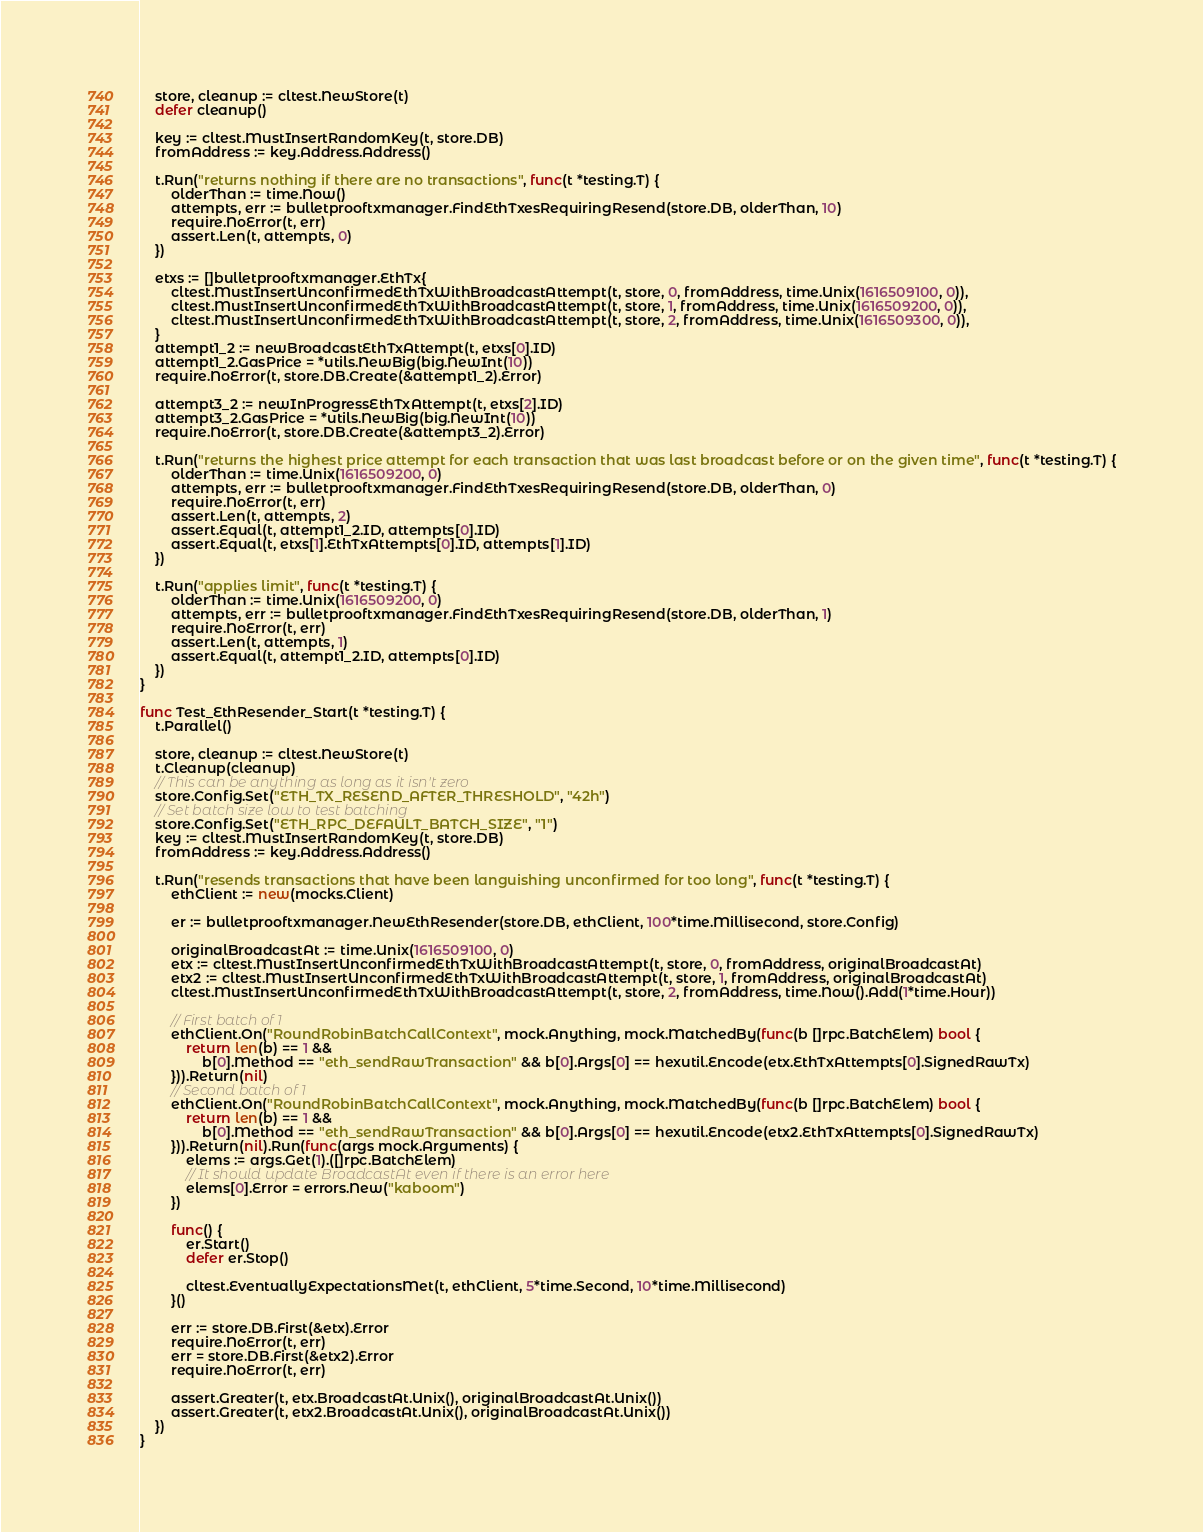<code> <loc_0><loc_0><loc_500><loc_500><_Go_>
	store, cleanup := cltest.NewStore(t)
	defer cleanup()

	key := cltest.MustInsertRandomKey(t, store.DB)
	fromAddress := key.Address.Address()

	t.Run("returns nothing if there are no transactions", func(t *testing.T) {
		olderThan := time.Now()
		attempts, err := bulletprooftxmanager.FindEthTxesRequiringResend(store.DB, olderThan, 10)
		require.NoError(t, err)
		assert.Len(t, attempts, 0)
	})

	etxs := []bulletprooftxmanager.EthTx{
		cltest.MustInsertUnconfirmedEthTxWithBroadcastAttempt(t, store, 0, fromAddress, time.Unix(1616509100, 0)),
		cltest.MustInsertUnconfirmedEthTxWithBroadcastAttempt(t, store, 1, fromAddress, time.Unix(1616509200, 0)),
		cltest.MustInsertUnconfirmedEthTxWithBroadcastAttempt(t, store, 2, fromAddress, time.Unix(1616509300, 0)),
	}
	attempt1_2 := newBroadcastEthTxAttempt(t, etxs[0].ID)
	attempt1_2.GasPrice = *utils.NewBig(big.NewInt(10))
	require.NoError(t, store.DB.Create(&attempt1_2).Error)

	attempt3_2 := newInProgressEthTxAttempt(t, etxs[2].ID)
	attempt3_2.GasPrice = *utils.NewBig(big.NewInt(10))
	require.NoError(t, store.DB.Create(&attempt3_2).Error)

	t.Run("returns the highest price attempt for each transaction that was last broadcast before or on the given time", func(t *testing.T) {
		olderThan := time.Unix(1616509200, 0)
		attempts, err := bulletprooftxmanager.FindEthTxesRequiringResend(store.DB, olderThan, 0)
		require.NoError(t, err)
		assert.Len(t, attempts, 2)
		assert.Equal(t, attempt1_2.ID, attempts[0].ID)
		assert.Equal(t, etxs[1].EthTxAttempts[0].ID, attempts[1].ID)
	})

	t.Run("applies limit", func(t *testing.T) {
		olderThan := time.Unix(1616509200, 0)
		attempts, err := bulletprooftxmanager.FindEthTxesRequiringResend(store.DB, olderThan, 1)
		require.NoError(t, err)
		assert.Len(t, attempts, 1)
		assert.Equal(t, attempt1_2.ID, attempts[0].ID)
	})
}

func Test_EthResender_Start(t *testing.T) {
	t.Parallel()

	store, cleanup := cltest.NewStore(t)
	t.Cleanup(cleanup)
	// This can be anything as long as it isn't zero
	store.Config.Set("ETH_TX_RESEND_AFTER_THRESHOLD", "42h")
	// Set batch size low to test batching
	store.Config.Set("ETH_RPC_DEFAULT_BATCH_SIZE", "1")
	key := cltest.MustInsertRandomKey(t, store.DB)
	fromAddress := key.Address.Address()

	t.Run("resends transactions that have been languishing unconfirmed for too long", func(t *testing.T) {
		ethClient := new(mocks.Client)

		er := bulletprooftxmanager.NewEthResender(store.DB, ethClient, 100*time.Millisecond, store.Config)

		originalBroadcastAt := time.Unix(1616509100, 0)
		etx := cltest.MustInsertUnconfirmedEthTxWithBroadcastAttempt(t, store, 0, fromAddress, originalBroadcastAt)
		etx2 := cltest.MustInsertUnconfirmedEthTxWithBroadcastAttempt(t, store, 1, fromAddress, originalBroadcastAt)
		cltest.MustInsertUnconfirmedEthTxWithBroadcastAttempt(t, store, 2, fromAddress, time.Now().Add(1*time.Hour))

		// First batch of 1
		ethClient.On("RoundRobinBatchCallContext", mock.Anything, mock.MatchedBy(func(b []rpc.BatchElem) bool {
			return len(b) == 1 &&
				b[0].Method == "eth_sendRawTransaction" && b[0].Args[0] == hexutil.Encode(etx.EthTxAttempts[0].SignedRawTx)
		})).Return(nil)
		// Second batch of 1
		ethClient.On("RoundRobinBatchCallContext", mock.Anything, mock.MatchedBy(func(b []rpc.BatchElem) bool {
			return len(b) == 1 &&
				b[0].Method == "eth_sendRawTransaction" && b[0].Args[0] == hexutil.Encode(etx2.EthTxAttempts[0].SignedRawTx)
		})).Return(nil).Run(func(args mock.Arguments) {
			elems := args.Get(1).([]rpc.BatchElem)
			// It should update BroadcastAt even if there is an error here
			elems[0].Error = errors.New("kaboom")
		})

		func() {
			er.Start()
			defer er.Stop()

			cltest.EventuallyExpectationsMet(t, ethClient, 5*time.Second, 10*time.Millisecond)
		}()

		err := store.DB.First(&etx).Error
		require.NoError(t, err)
		err = store.DB.First(&etx2).Error
		require.NoError(t, err)

		assert.Greater(t, etx.BroadcastAt.Unix(), originalBroadcastAt.Unix())
		assert.Greater(t, etx2.BroadcastAt.Unix(), originalBroadcastAt.Unix())
	})
}
</code> 